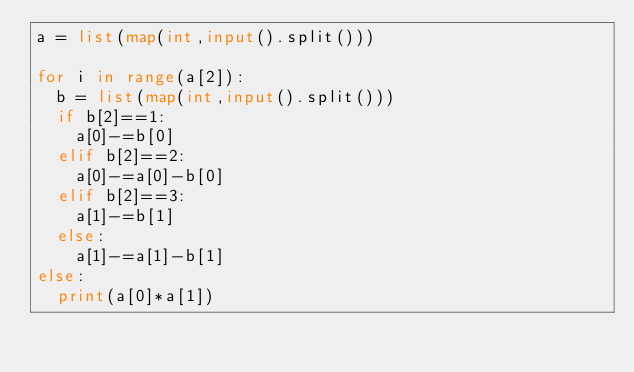<code> <loc_0><loc_0><loc_500><loc_500><_Python_>a = list(map(int,input().split()))

for i in range(a[2]):
  b = list(map(int,input().split()))
  if b[2]==1:
    a[0]-=b[0]
  elif b[2]==2:
    a[0]-=a[0]-b[0]
  elif b[2]==3:
    a[1]-=b[1]
  else:
    a[1]-=a[1]-b[1]
else:
  print(a[0]*a[1])</code> 